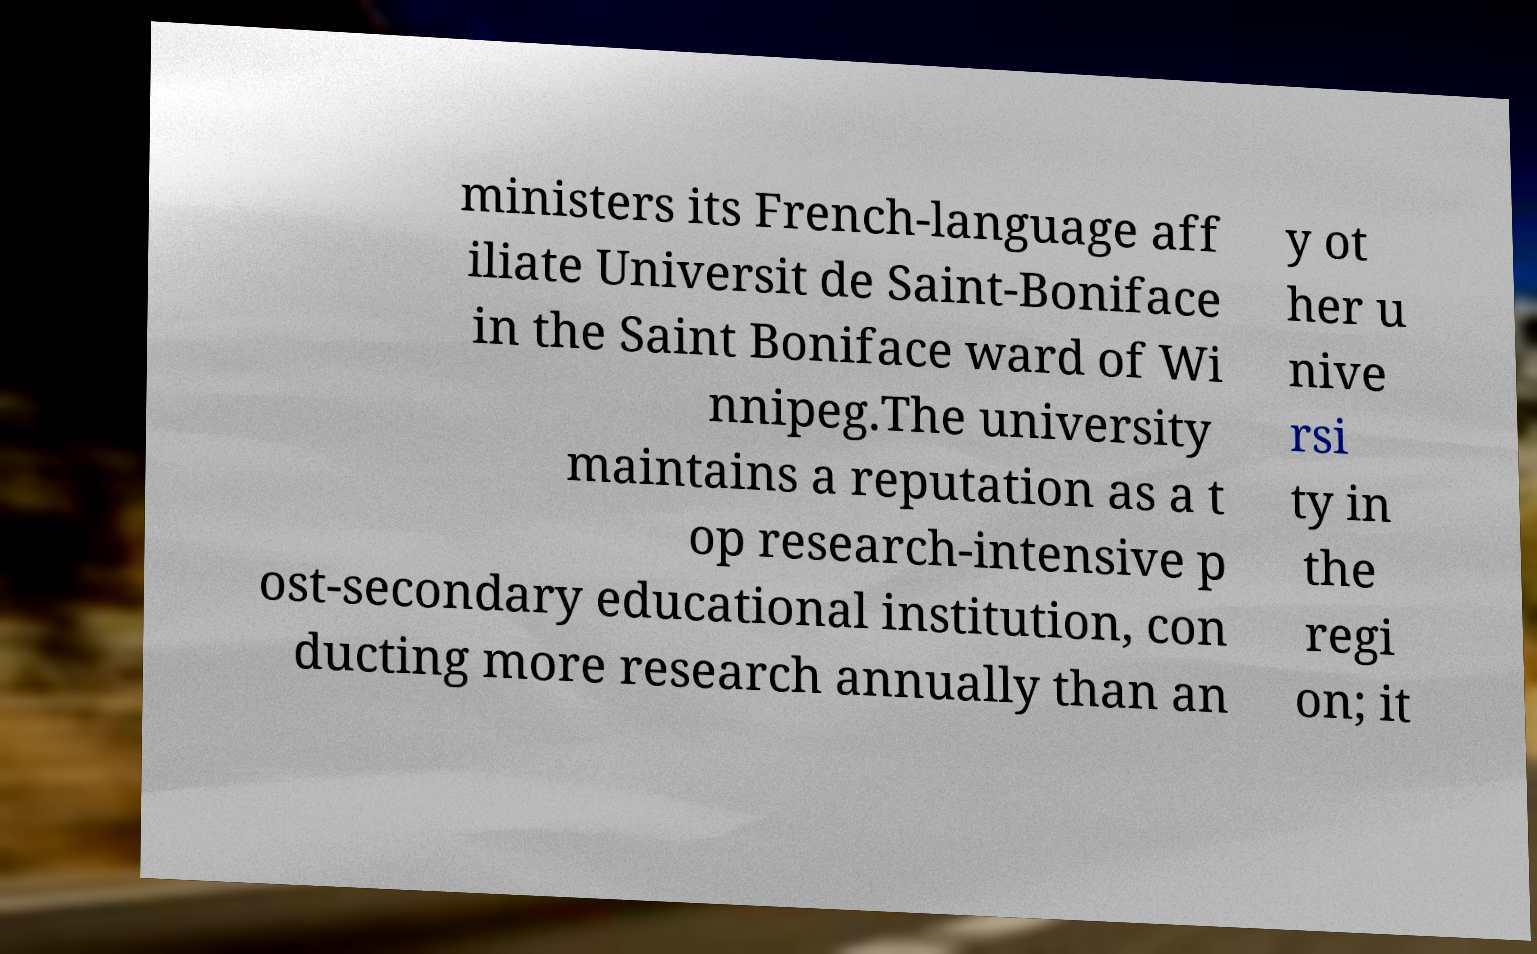I need the written content from this picture converted into text. Can you do that? ministers its French-language aff iliate Universit de Saint-Boniface in the Saint Boniface ward of Wi nnipeg.The university maintains a reputation as a t op research-intensive p ost-secondary educational institution, con ducting more research annually than an y ot her u nive rsi ty in the regi on; it 